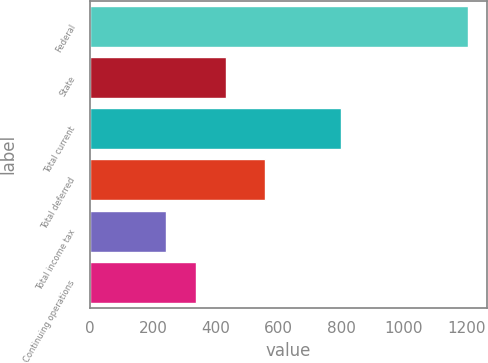<chart> <loc_0><loc_0><loc_500><loc_500><bar_chart><fcel>Federal<fcel>State<fcel>Total current<fcel>Total deferred<fcel>Total income tax<fcel>Continuing operations<nl><fcel>1205<fcel>433<fcel>798<fcel>558<fcel>240<fcel>336.5<nl></chart> 